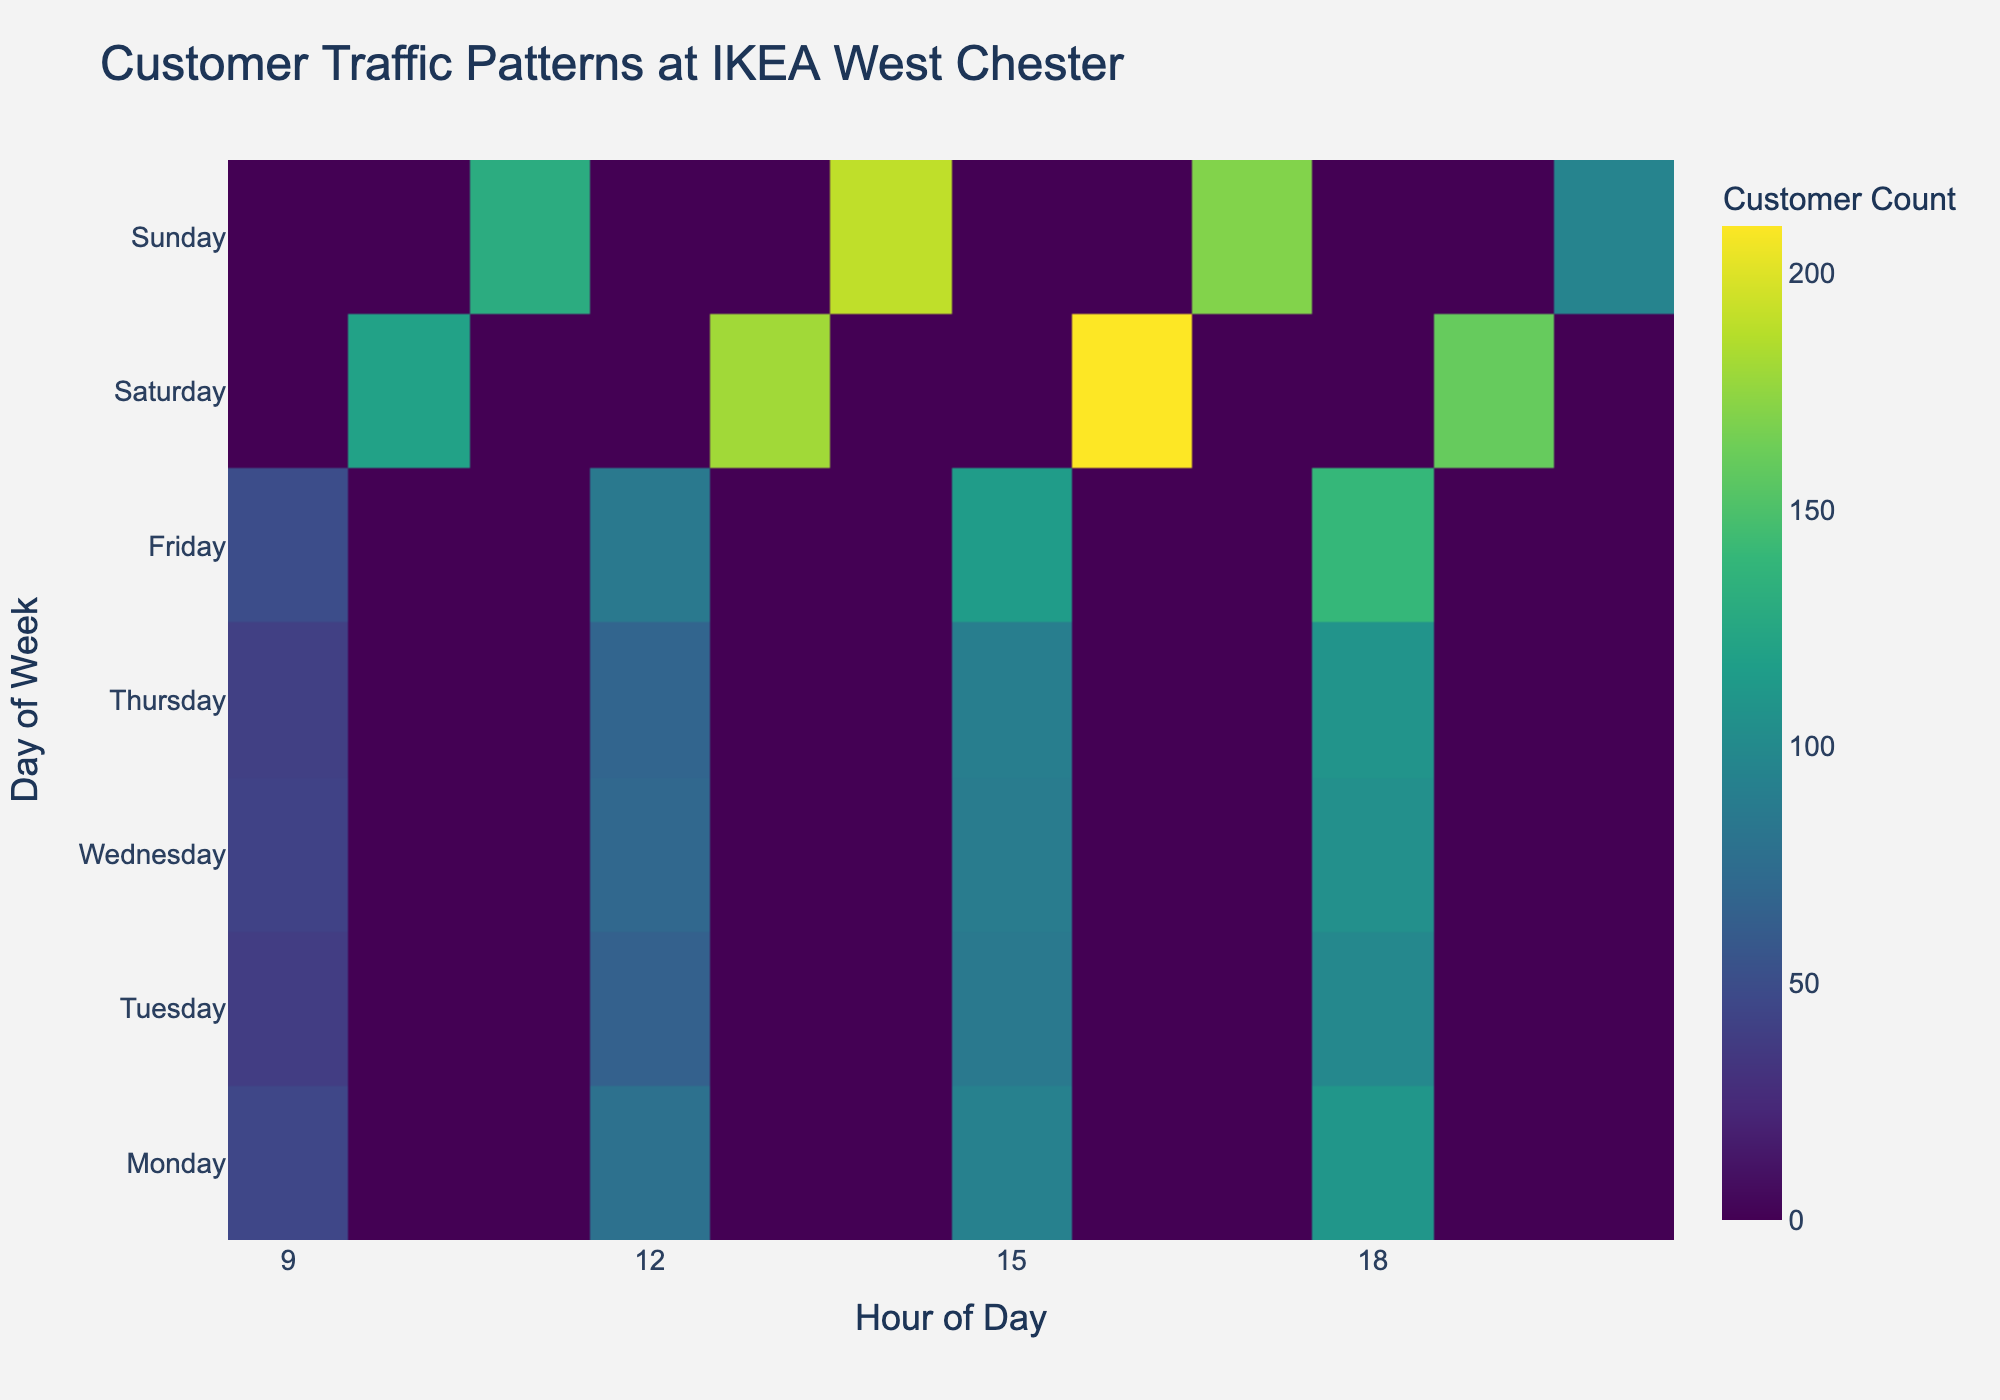What is the title of the figure? The title is usually located at the top of the figure. In this case, the title provided in the code is "Customer Traffic Patterns at IKEA West Chester".
Answer: Customer Traffic Patterns at IKEA West Chester Which day has the highest customer traffic in the evening? To determine this, identify the hexbin with the highest intensity during the evening hours (15:00 - 18:00) and match it to the corresponding day.
Answer: Saturday What is the color used for representing the highest customer count? The color of the highest customer count can be identified by looking at the legend or colorbar which typically represents the intensity.
Answer: Dark Yellow-Green How does customer traffic on weekdays compare to weekends? Compare the intensity of the hexagons for weekdays (Monday to Friday) with the intensity on weekends (Saturday and Sunday). Weekends generally have more intense colors indicating higher customer traffic.
Answer: Weekends have higher traffic During which hour of the day does the store see the peak customer count? Examine the x-axis to find the hour with the most intense hexbin across all days.
Answer: 14:00 What are the customer traffic patterns in the early morning between weekdays and weekends? Compare the intensities of the hexagons between weekdays (Monday to Friday) and weekends (Saturday and Sunday) for the early morning hours (9:00 - 11:00). Weekends show higher traffic during early hours.
Answer: Weekends have higher traffic Which day has the lowest customer traffic at noon? Look at the hexbin intensity around 12:00 hours for each day and find the day with the least intensity.
Answer: Tuesday How evenly distributed is the customer traffic throughout the store hours on Sunday? Analyze the pattern of hexbin intensity on the y-axis for Sunday across different hours to see if the colors are consistent or vary a lot.
Answer: Fairly even Compare Wednesday and Thursday afternoon traffic. Evaluate the hexbin intensities during the afternoon hours (15:00 - 18:00) for Wednesday and Thursday to compare their traffic.
Answer: Almost the same How does the customer count vary from morning to evening on Friday? Follow the hexbin intensities along Friday from morning (9:00) to evening (18:00) to observe the change in traffic patterns.
Answer: It increases 